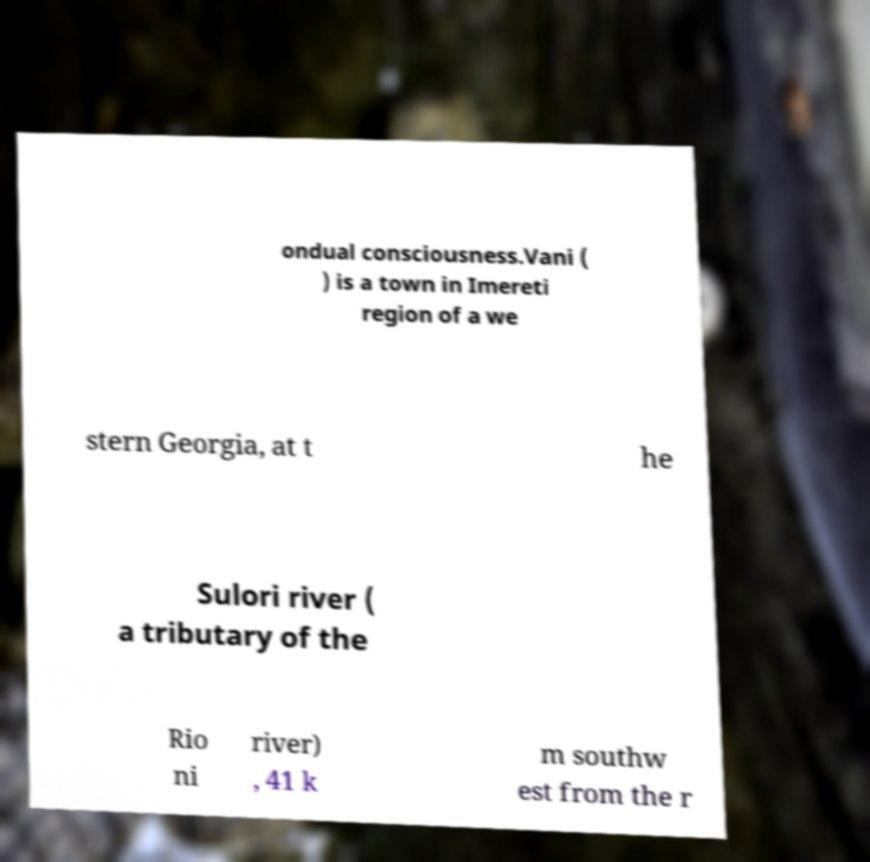Please identify and transcribe the text found in this image. ondual consciousness.Vani ( ) is a town in Imereti region of a we stern Georgia, at t he Sulori river ( a tributary of the Rio ni river) , 41 k m southw est from the r 